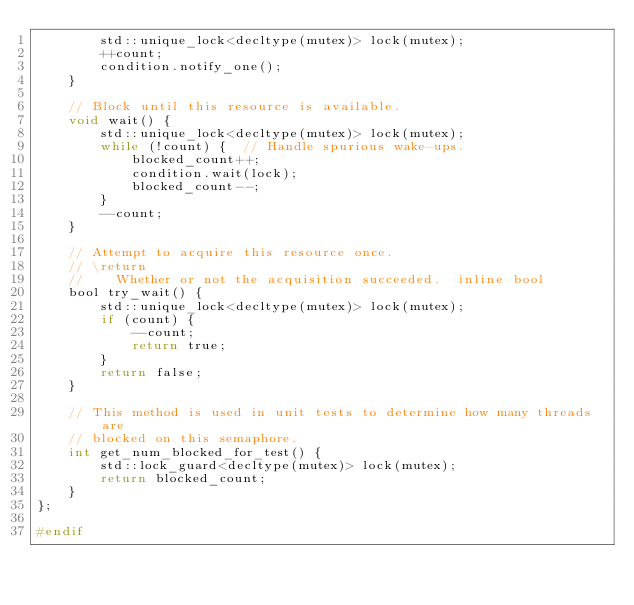Convert code to text. <code><loc_0><loc_0><loc_500><loc_500><_C_>        std::unique_lock<decltype(mutex)> lock(mutex);
        ++count;
        condition.notify_one();
    }

    // Block until this resource is available.
    void wait() {
        std::unique_lock<decltype(mutex)> lock(mutex);
        while (!count) {  // Handle spurious wake-ups.
            blocked_count++;
            condition.wait(lock);
            blocked_count--;
        }
        --count;
    }

    // Attempt to acquire this resource once.
    // \return
    //    Whether or not the acquisition succeeded.  inline bool
    bool try_wait() {
        std::unique_lock<decltype(mutex)> lock(mutex);
        if (count) {
            --count;
            return true;
        }
        return false;
    }

    // This method is used in unit tests to determine how many threads are
    // blocked on this semaphore.
    int get_num_blocked_for_test() {
        std::lock_guard<decltype(mutex)> lock(mutex);
        return blocked_count;
    }
};

#endif
</code> 